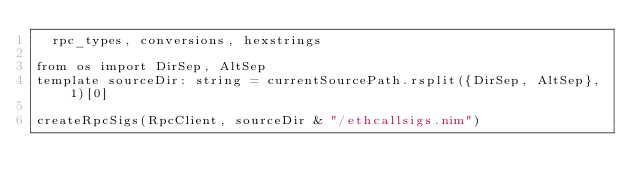Convert code to text. <code><loc_0><loc_0><loc_500><loc_500><_Nim_>  rpc_types, conversions, hexstrings

from os import DirSep, AltSep
template sourceDir: string = currentSourcePath.rsplit({DirSep, AltSep}, 1)[0]

createRpcSigs(RpcClient, sourceDir & "/ethcallsigs.nim")
</code> 